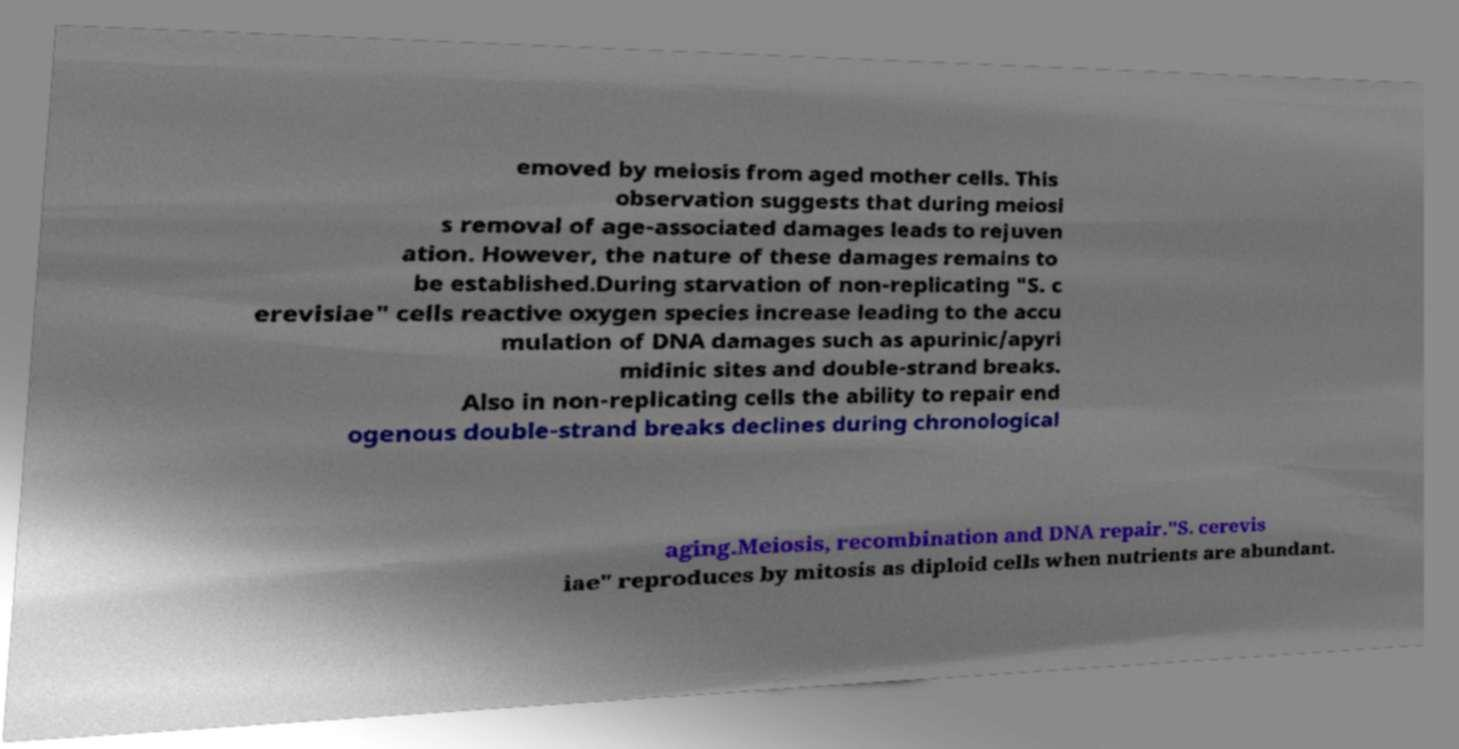Please read and relay the text visible in this image. What does it say? emoved by meiosis from aged mother cells. This observation suggests that during meiosi s removal of age-associated damages leads to rejuven ation. However, the nature of these damages remains to be established.During starvation of non-replicating "S. c erevisiae" cells reactive oxygen species increase leading to the accu mulation of DNA damages such as apurinic/apyri midinic sites and double-strand breaks. Also in non-replicating cells the ability to repair end ogenous double-strand breaks declines during chronological aging.Meiosis, recombination and DNA repair."S. cerevis iae" reproduces by mitosis as diploid cells when nutrients are abundant. 